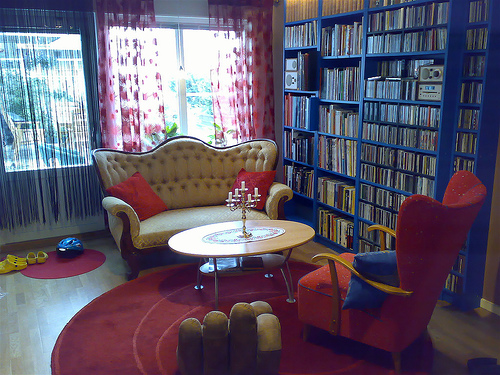<image>
Is there a book on the table? No. The book is not positioned on the table. They may be near each other, but the book is not supported by or resting on top of the table. Is the rug behind the table? No. The rug is not behind the table. From this viewpoint, the rug appears to be positioned elsewhere in the scene. 